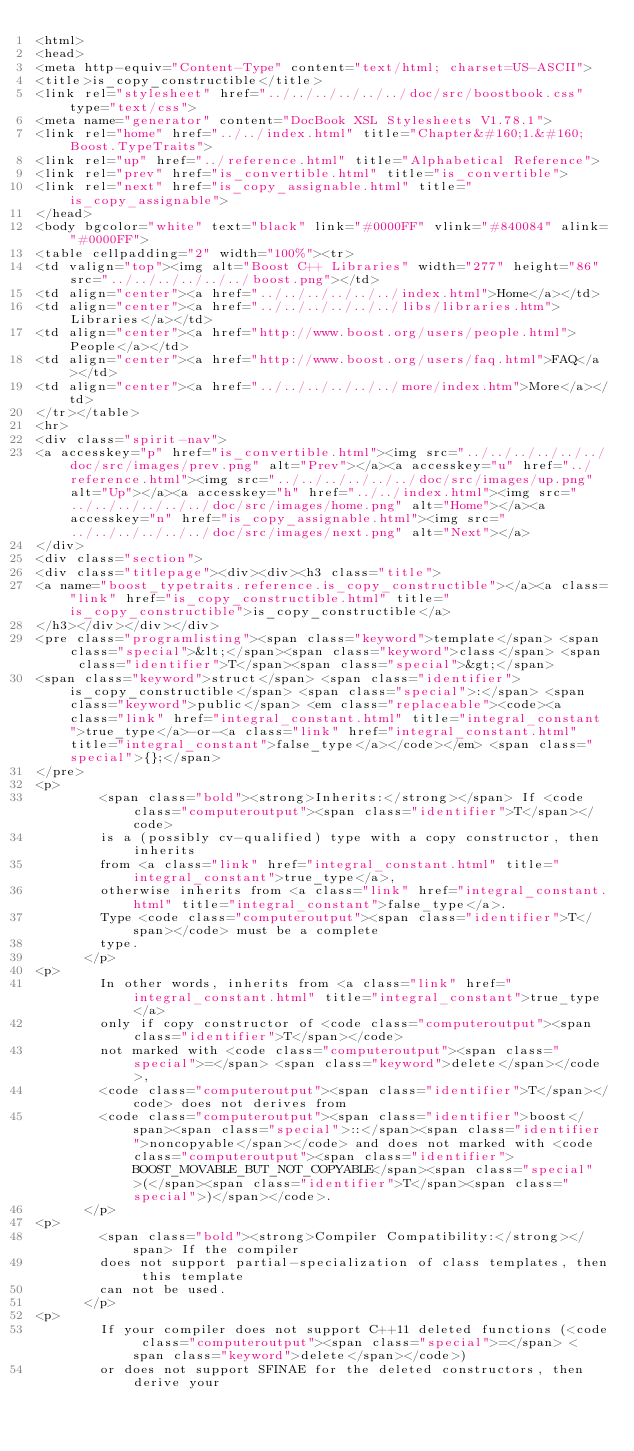<code> <loc_0><loc_0><loc_500><loc_500><_HTML_><html>
<head>
<meta http-equiv="Content-Type" content="text/html; charset=US-ASCII">
<title>is_copy_constructible</title>
<link rel="stylesheet" href="../../../../../../doc/src/boostbook.css" type="text/css">
<meta name="generator" content="DocBook XSL Stylesheets V1.78.1">
<link rel="home" href="../../index.html" title="Chapter&#160;1.&#160;Boost.TypeTraits">
<link rel="up" href="../reference.html" title="Alphabetical Reference">
<link rel="prev" href="is_convertible.html" title="is_convertible">
<link rel="next" href="is_copy_assignable.html" title="is_copy_assignable">
</head>
<body bgcolor="white" text="black" link="#0000FF" vlink="#840084" alink="#0000FF">
<table cellpadding="2" width="100%"><tr>
<td valign="top"><img alt="Boost C++ Libraries" width="277" height="86" src="../../../../../../boost.png"></td>
<td align="center"><a href="../../../../../../index.html">Home</a></td>
<td align="center"><a href="../../../../../../libs/libraries.htm">Libraries</a></td>
<td align="center"><a href="http://www.boost.org/users/people.html">People</a></td>
<td align="center"><a href="http://www.boost.org/users/faq.html">FAQ</a></td>
<td align="center"><a href="../../../../../../more/index.htm">More</a></td>
</tr></table>
<hr>
<div class="spirit-nav">
<a accesskey="p" href="is_convertible.html"><img src="../../../../../../doc/src/images/prev.png" alt="Prev"></a><a accesskey="u" href="../reference.html"><img src="../../../../../../doc/src/images/up.png" alt="Up"></a><a accesskey="h" href="../../index.html"><img src="../../../../../../doc/src/images/home.png" alt="Home"></a><a accesskey="n" href="is_copy_assignable.html"><img src="../../../../../../doc/src/images/next.png" alt="Next"></a>
</div>
<div class="section">
<div class="titlepage"><div><div><h3 class="title">
<a name="boost_typetraits.reference.is_copy_constructible"></a><a class="link" href="is_copy_constructible.html" title="is_copy_constructible">is_copy_constructible</a>
</h3></div></div></div>
<pre class="programlisting"><span class="keyword">template</span> <span class="special">&lt;</span><span class="keyword">class</span> <span class="identifier">T</span><span class="special">&gt;</span>
<span class="keyword">struct</span> <span class="identifier">is_copy_constructible</span> <span class="special">:</span> <span class="keyword">public</span> <em class="replaceable"><code><a class="link" href="integral_constant.html" title="integral_constant">true_type</a>-or-<a class="link" href="integral_constant.html" title="integral_constant">false_type</a></code></em> <span class="special">{};</span>
</pre>
<p>
        <span class="bold"><strong>Inherits:</strong></span> If <code class="computeroutput"><span class="identifier">T</span></code>
        is a (possibly cv-qualified) type with a copy constructor, then inherits
        from <a class="link" href="integral_constant.html" title="integral_constant">true_type</a>,
        otherwise inherits from <a class="link" href="integral_constant.html" title="integral_constant">false_type</a>.
        Type <code class="computeroutput"><span class="identifier">T</span></code> must be a complete
        type.
      </p>
<p>
        In other words, inherits from <a class="link" href="integral_constant.html" title="integral_constant">true_type</a>
        only if copy constructor of <code class="computeroutput"><span class="identifier">T</span></code>
        not marked with <code class="computeroutput"><span class="special">=</span> <span class="keyword">delete</span></code>,
        <code class="computeroutput"><span class="identifier">T</span></code> does not derives from
        <code class="computeroutput"><span class="identifier">boost</span><span class="special">::</span><span class="identifier">noncopyable</span></code> and does not marked with <code class="computeroutput"><span class="identifier">BOOST_MOVABLE_BUT_NOT_COPYABLE</span><span class="special">(</span><span class="identifier">T</span><span class="special">)</span></code>.
      </p>
<p>
        <span class="bold"><strong>Compiler Compatibility:</strong></span> If the compiler
        does not support partial-specialization of class templates, then this template
        can not be used.
      </p>
<p>
        If your compiler does not support C++11 deleted functions (<code class="computeroutput"><span class="special">=</span> <span class="keyword">delete</span></code>)
        or does not support SFINAE for the deleted constructors, then derive your</code> 